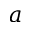Convert formula to latex. <formula><loc_0><loc_0><loc_500><loc_500>a</formula> 